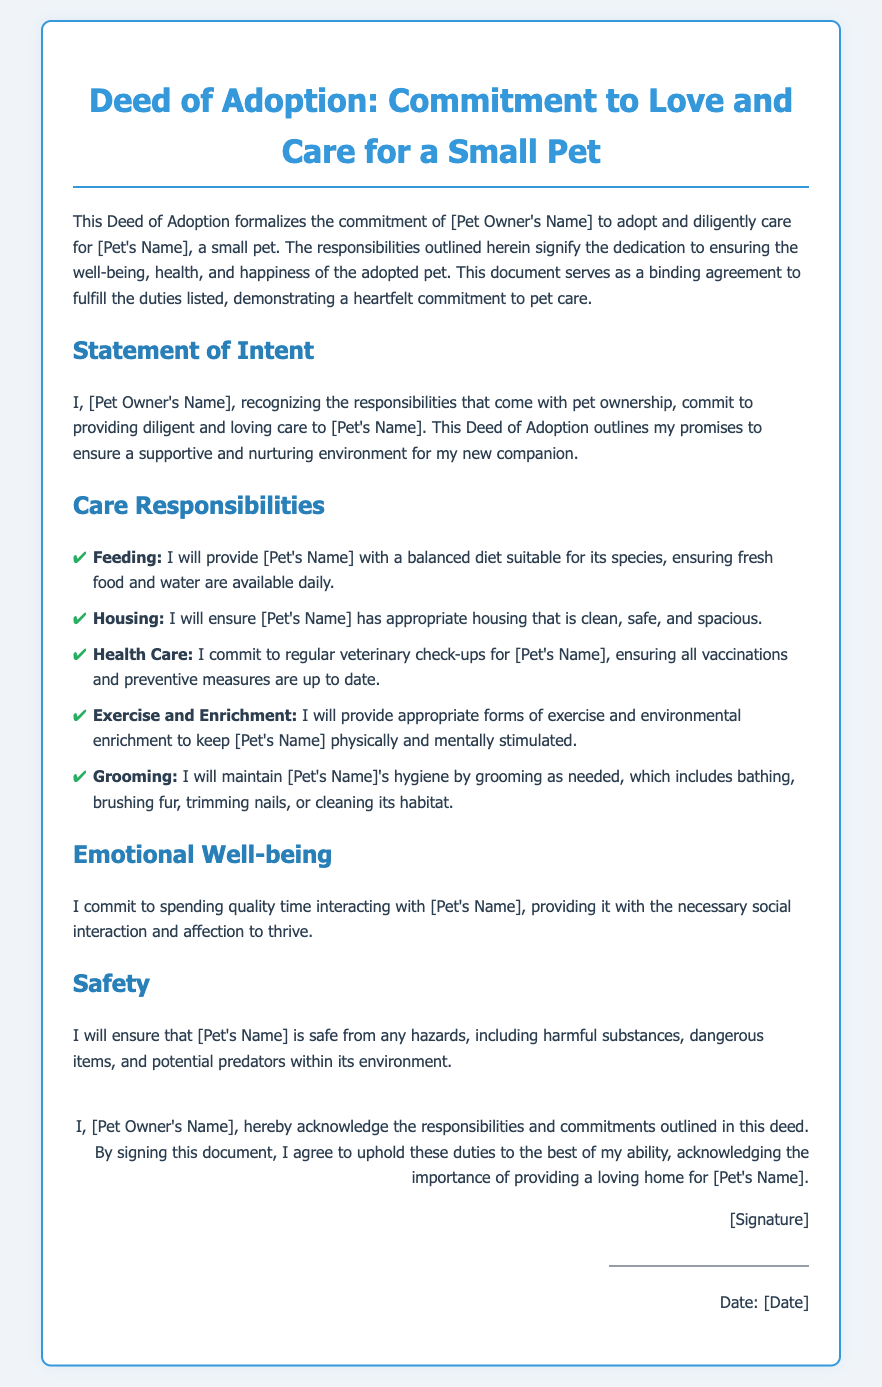What is the title of the document? The title of the document is the main header that describes it, which is located at the top.
Answer: Deed of Adoption: Commitment to Love and Care for a Small Pet Who is the pet owner's name? The pet owner's name is mentioned in the introductory paragraph and signature section as the person responsible for the pet's care.
Answer: [Pet Owner's Name] What type of pet is being adopted? The type of pet being adopted is specified in the introductory paragraph following the pet owner's name.
Answer: [Pet's Name] How many care responsibilities are outlined in the document? The number of care responsibilities can be counted by looking at the list provided in the responsibilities section.
Answer: Five What is one of the commitments related to health care? The commitments related to health care can be found listed under the responsibilities section, specifically about veterinary care.
Answer: Regular veterinary check-ups What is mentioned under Emotional Well-being? The document outlines what the pet owner commits to in terms of the pet's emotional needs.
Answer: Spending quality time interacting with [Pet's Name] What does the pet owner acknowledge by signing the document? The acknowledgment by the pet owner is stated in the signature section, noting their commitment to care for the pet.
Answer: Responsibilities and commitments outlined in this deed What is the date placeholder for? The date placeholder indicates when the document will be officially signed and acknowledged by the pet owner.
Answer: [Date] 